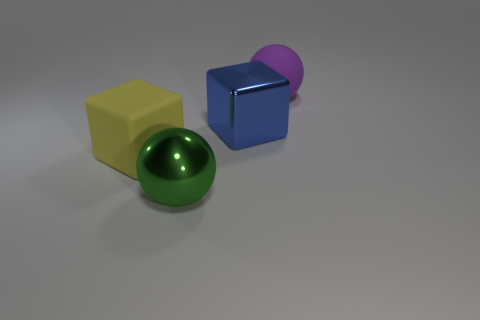Subtract all red spheres. Subtract all purple cylinders. How many spheres are left? 2 Add 3 yellow objects. How many objects exist? 7 Add 1 big yellow matte blocks. How many big yellow matte blocks are left? 2 Add 4 big things. How many big things exist? 8 Subtract 0 yellow spheres. How many objects are left? 4 Subtract all small gray blocks. Subtract all shiny objects. How many objects are left? 2 